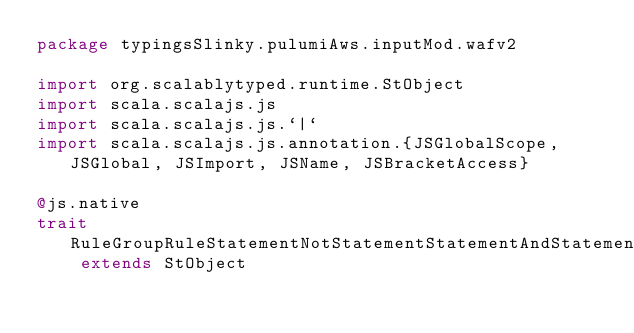Convert code to text. <code><loc_0><loc_0><loc_500><loc_500><_Scala_>package typingsSlinky.pulumiAws.inputMod.wafv2

import org.scalablytyped.runtime.StObject
import scala.scalajs.js
import scala.scalajs.js.`|`
import scala.scalajs.js.annotation.{JSGlobalScope, JSGlobal, JSImport, JSName, JSBracketAccess}

@js.native
trait RuleGroupRuleStatementNotStatementStatementAndStatementStatementByteMatchStatementFieldToMatchAllQueryArguments extends StObject
</code> 